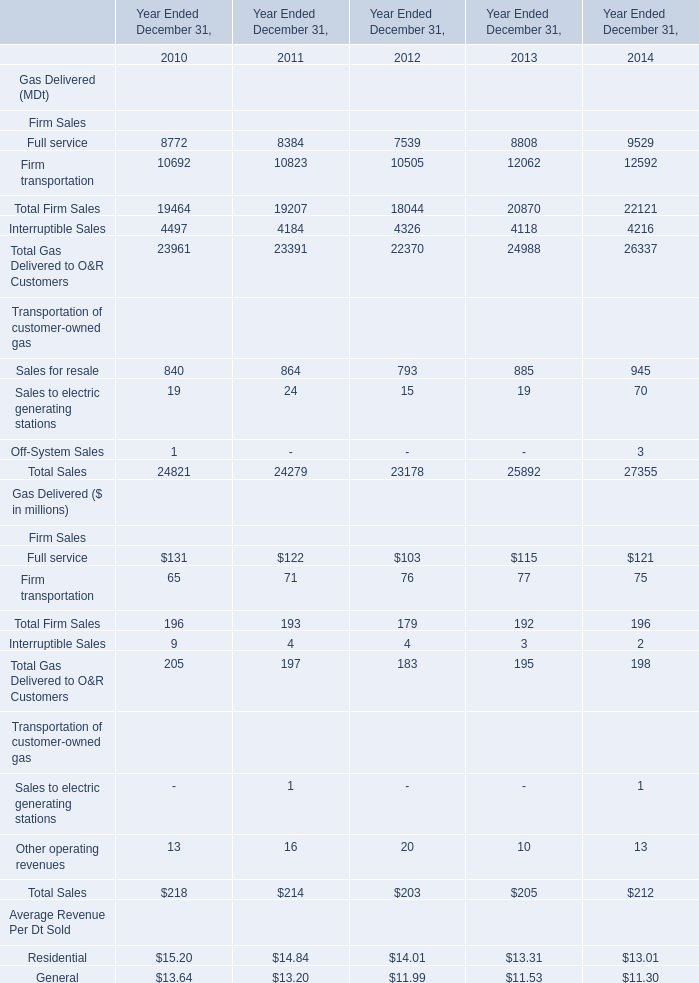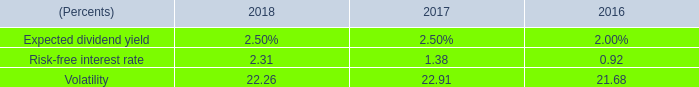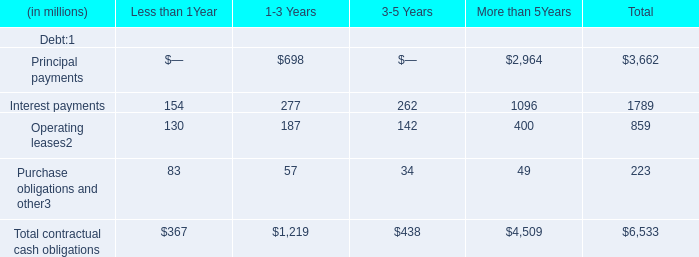what was the percentage change in dollars spent on share repurchase between 2016 and 2017? 
Computations: ((359.8 - 540.1) / 540.1)
Answer: -0.33383. 